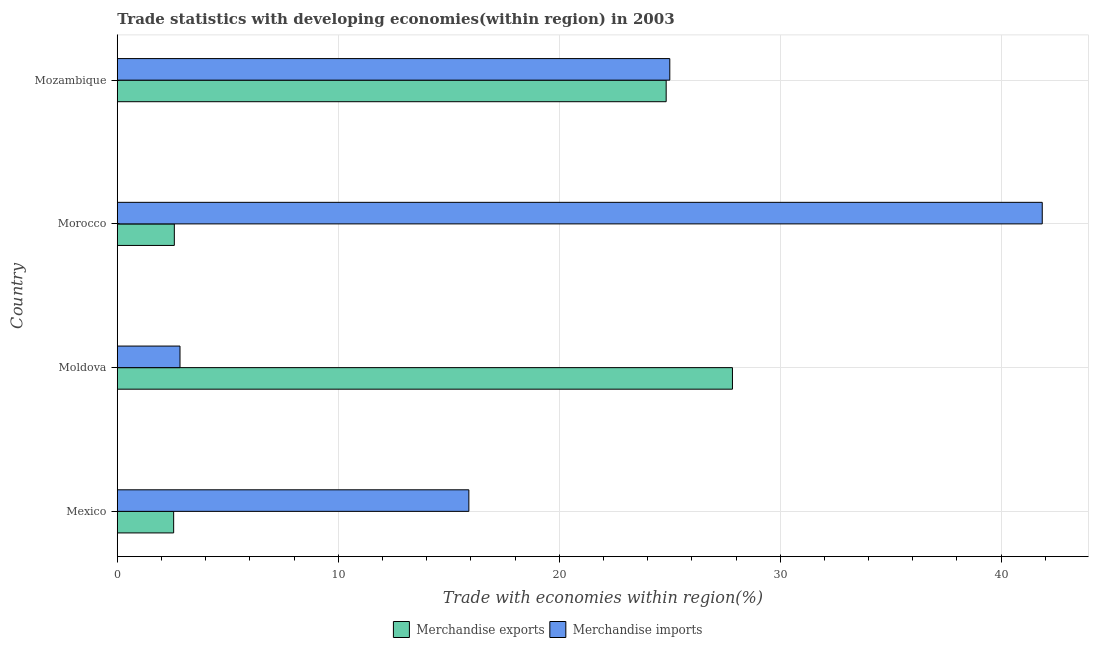How many groups of bars are there?
Your answer should be very brief. 4. What is the label of the 1st group of bars from the top?
Offer a very short reply. Mozambique. What is the merchandise exports in Mexico?
Give a very brief answer. 2.55. Across all countries, what is the maximum merchandise exports?
Ensure brevity in your answer.  27.84. Across all countries, what is the minimum merchandise imports?
Offer a terse response. 2.84. In which country was the merchandise imports maximum?
Offer a very short reply. Morocco. In which country was the merchandise imports minimum?
Provide a succinct answer. Moldova. What is the total merchandise imports in the graph?
Make the answer very short. 85.61. What is the difference between the merchandise imports in Moldova and that in Morocco?
Offer a terse response. -39.02. What is the difference between the merchandise imports in Mexico and the merchandise exports in Morocco?
Provide a succinct answer. 13.33. What is the average merchandise exports per country?
Provide a succinct answer. 14.45. What is the difference between the merchandise exports and merchandise imports in Moldova?
Your answer should be very brief. 25. In how many countries, is the merchandise imports greater than 36 %?
Offer a terse response. 1. What is the ratio of the merchandise exports in Moldova to that in Morocco?
Keep it short and to the point. 10.79. What is the difference between the highest and the second highest merchandise imports?
Your response must be concise. 16.86. What is the difference between the highest and the lowest merchandise imports?
Your answer should be very brief. 39.02. In how many countries, is the merchandise exports greater than the average merchandise exports taken over all countries?
Provide a short and direct response. 2. What does the 2nd bar from the top in Morocco represents?
Give a very brief answer. Merchandise exports. How many bars are there?
Your response must be concise. 8. Where does the legend appear in the graph?
Provide a succinct answer. Bottom center. How are the legend labels stacked?
Offer a terse response. Horizontal. What is the title of the graph?
Your response must be concise. Trade statistics with developing economies(within region) in 2003. Does "Banks" appear as one of the legend labels in the graph?
Keep it short and to the point. No. What is the label or title of the X-axis?
Ensure brevity in your answer.  Trade with economies within region(%). What is the Trade with economies within region(%) of Merchandise exports in Mexico?
Give a very brief answer. 2.55. What is the Trade with economies within region(%) of Merchandise imports in Mexico?
Provide a succinct answer. 15.91. What is the Trade with economies within region(%) of Merchandise exports in Moldova?
Provide a succinct answer. 27.84. What is the Trade with economies within region(%) of Merchandise imports in Moldova?
Offer a very short reply. 2.84. What is the Trade with economies within region(%) of Merchandise exports in Morocco?
Provide a succinct answer. 2.58. What is the Trade with economies within region(%) in Merchandise imports in Morocco?
Ensure brevity in your answer.  41.86. What is the Trade with economies within region(%) of Merchandise exports in Mozambique?
Offer a terse response. 24.84. What is the Trade with economies within region(%) of Merchandise imports in Mozambique?
Provide a short and direct response. 25. Across all countries, what is the maximum Trade with economies within region(%) of Merchandise exports?
Your answer should be compact. 27.84. Across all countries, what is the maximum Trade with economies within region(%) of Merchandise imports?
Offer a very short reply. 41.86. Across all countries, what is the minimum Trade with economies within region(%) in Merchandise exports?
Offer a very short reply. 2.55. Across all countries, what is the minimum Trade with economies within region(%) in Merchandise imports?
Provide a succinct answer. 2.84. What is the total Trade with economies within region(%) of Merchandise exports in the graph?
Your answer should be compact. 57.81. What is the total Trade with economies within region(%) in Merchandise imports in the graph?
Provide a short and direct response. 85.61. What is the difference between the Trade with economies within region(%) in Merchandise exports in Mexico and that in Moldova?
Ensure brevity in your answer.  -25.29. What is the difference between the Trade with economies within region(%) in Merchandise imports in Mexico and that in Moldova?
Your answer should be very brief. 13.07. What is the difference between the Trade with economies within region(%) of Merchandise exports in Mexico and that in Morocco?
Offer a very short reply. -0.03. What is the difference between the Trade with economies within region(%) of Merchandise imports in Mexico and that in Morocco?
Provide a succinct answer. -25.95. What is the difference between the Trade with economies within region(%) in Merchandise exports in Mexico and that in Mozambique?
Ensure brevity in your answer.  -22.29. What is the difference between the Trade with economies within region(%) of Merchandise imports in Mexico and that in Mozambique?
Offer a very short reply. -9.09. What is the difference between the Trade with economies within region(%) of Merchandise exports in Moldova and that in Morocco?
Make the answer very short. 25.26. What is the difference between the Trade with economies within region(%) in Merchandise imports in Moldova and that in Morocco?
Your answer should be very brief. -39.02. What is the difference between the Trade with economies within region(%) of Merchandise exports in Moldova and that in Mozambique?
Give a very brief answer. 3. What is the difference between the Trade with economies within region(%) of Merchandise imports in Moldova and that in Mozambique?
Provide a short and direct response. -22.17. What is the difference between the Trade with economies within region(%) in Merchandise exports in Morocco and that in Mozambique?
Ensure brevity in your answer.  -22.26. What is the difference between the Trade with economies within region(%) in Merchandise imports in Morocco and that in Mozambique?
Your response must be concise. 16.86. What is the difference between the Trade with economies within region(%) of Merchandise exports in Mexico and the Trade with economies within region(%) of Merchandise imports in Moldova?
Your answer should be very brief. -0.29. What is the difference between the Trade with economies within region(%) in Merchandise exports in Mexico and the Trade with economies within region(%) in Merchandise imports in Morocco?
Offer a terse response. -39.31. What is the difference between the Trade with economies within region(%) of Merchandise exports in Mexico and the Trade with economies within region(%) of Merchandise imports in Mozambique?
Keep it short and to the point. -22.45. What is the difference between the Trade with economies within region(%) in Merchandise exports in Moldova and the Trade with economies within region(%) in Merchandise imports in Morocco?
Your response must be concise. -14.02. What is the difference between the Trade with economies within region(%) in Merchandise exports in Moldova and the Trade with economies within region(%) in Merchandise imports in Mozambique?
Offer a terse response. 2.84. What is the difference between the Trade with economies within region(%) of Merchandise exports in Morocco and the Trade with economies within region(%) of Merchandise imports in Mozambique?
Provide a short and direct response. -22.42. What is the average Trade with economies within region(%) in Merchandise exports per country?
Give a very brief answer. 14.45. What is the average Trade with economies within region(%) of Merchandise imports per country?
Ensure brevity in your answer.  21.4. What is the difference between the Trade with economies within region(%) of Merchandise exports and Trade with economies within region(%) of Merchandise imports in Mexico?
Offer a terse response. -13.36. What is the difference between the Trade with economies within region(%) in Merchandise exports and Trade with economies within region(%) in Merchandise imports in Moldova?
Your answer should be compact. 25. What is the difference between the Trade with economies within region(%) in Merchandise exports and Trade with economies within region(%) in Merchandise imports in Morocco?
Offer a very short reply. -39.28. What is the difference between the Trade with economies within region(%) of Merchandise exports and Trade with economies within region(%) of Merchandise imports in Mozambique?
Your response must be concise. -0.16. What is the ratio of the Trade with economies within region(%) of Merchandise exports in Mexico to that in Moldova?
Your response must be concise. 0.09. What is the ratio of the Trade with economies within region(%) in Merchandise imports in Mexico to that in Moldova?
Provide a succinct answer. 5.61. What is the ratio of the Trade with economies within region(%) in Merchandise exports in Mexico to that in Morocco?
Make the answer very short. 0.99. What is the ratio of the Trade with economies within region(%) in Merchandise imports in Mexico to that in Morocco?
Make the answer very short. 0.38. What is the ratio of the Trade with economies within region(%) in Merchandise exports in Mexico to that in Mozambique?
Your answer should be compact. 0.1. What is the ratio of the Trade with economies within region(%) in Merchandise imports in Mexico to that in Mozambique?
Your response must be concise. 0.64. What is the ratio of the Trade with economies within region(%) in Merchandise exports in Moldova to that in Morocco?
Give a very brief answer. 10.79. What is the ratio of the Trade with economies within region(%) of Merchandise imports in Moldova to that in Morocco?
Make the answer very short. 0.07. What is the ratio of the Trade with economies within region(%) in Merchandise exports in Moldova to that in Mozambique?
Offer a very short reply. 1.12. What is the ratio of the Trade with economies within region(%) of Merchandise imports in Moldova to that in Mozambique?
Make the answer very short. 0.11. What is the ratio of the Trade with economies within region(%) in Merchandise exports in Morocco to that in Mozambique?
Provide a short and direct response. 0.1. What is the ratio of the Trade with economies within region(%) in Merchandise imports in Morocco to that in Mozambique?
Provide a succinct answer. 1.67. What is the difference between the highest and the second highest Trade with economies within region(%) of Merchandise exports?
Your answer should be compact. 3. What is the difference between the highest and the second highest Trade with economies within region(%) of Merchandise imports?
Offer a very short reply. 16.86. What is the difference between the highest and the lowest Trade with economies within region(%) in Merchandise exports?
Keep it short and to the point. 25.29. What is the difference between the highest and the lowest Trade with economies within region(%) in Merchandise imports?
Make the answer very short. 39.02. 